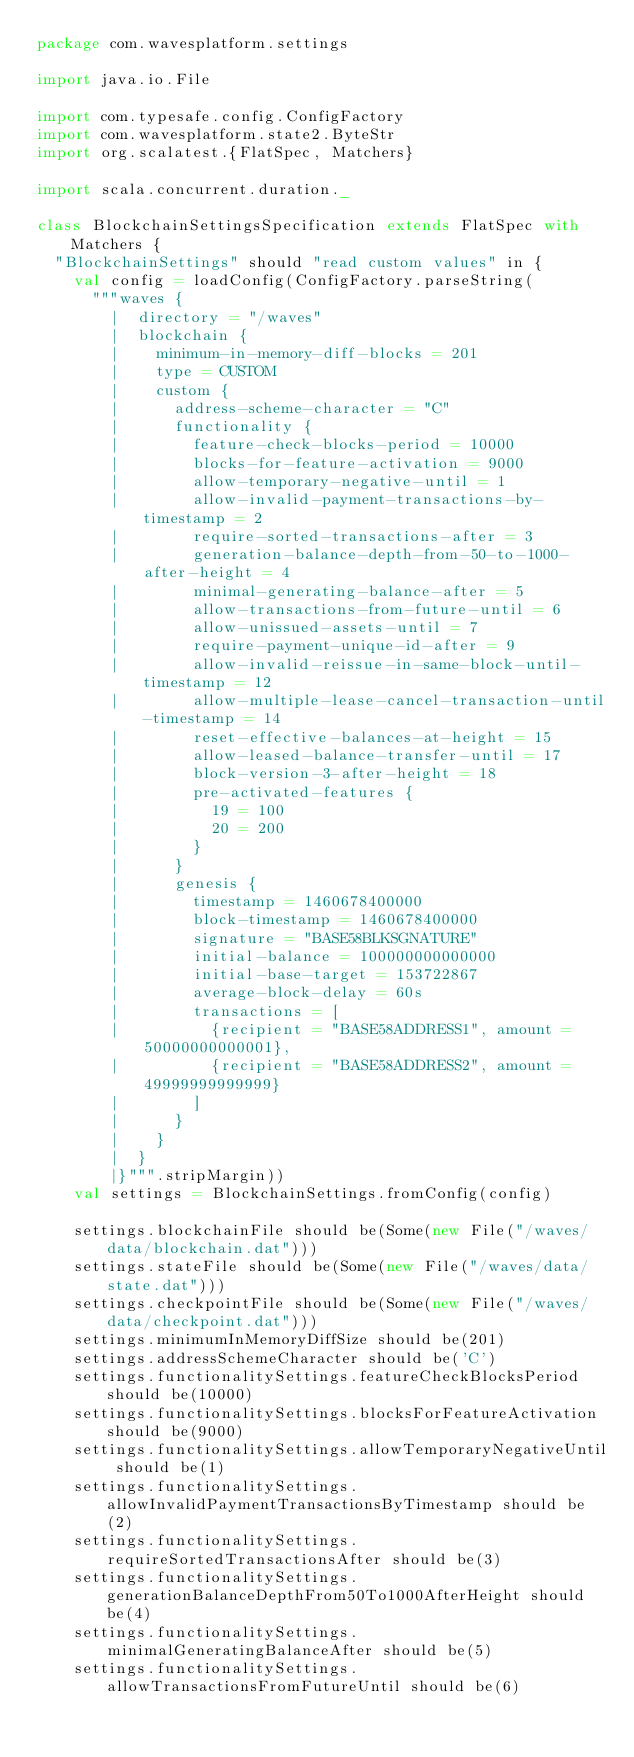<code> <loc_0><loc_0><loc_500><loc_500><_Scala_>package com.wavesplatform.settings

import java.io.File

import com.typesafe.config.ConfigFactory
import com.wavesplatform.state2.ByteStr
import org.scalatest.{FlatSpec, Matchers}

import scala.concurrent.duration._

class BlockchainSettingsSpecification extends FlatSpec with Matchers {
  "BlockchainSettings" should "read custom values" in {
    val config = loadConfig(ConfigFactory.parseString(
      """waves {
        |  directory = "/waves"
        |  blockchain {
        |    minimum-in-memory-diff-blocks = 201
        |    type = CUSTOM
        |    custom {
        |      address-scheme-character = "C"
        |      functionality {
        |        feature-check-blocks-period = 10000
        |        blocks-for-feature-activation = 9000
        |        allow-temporary-negative-until = 1
        |        allow-invalid-payment-transactions-by-timestamp = 2
        |        require-sorted-transactions-after = 3
        |        generation-balance-depth-from-50-to-1000-after-height = 4
        |        minimal-generating-balance-after = 5
        |        allow-transactions-from-future-until = 6
        |        allow-unissued-assets-until = 7
        |        require-payment-unique-id-after = 9
        |        allow-invalid-reissue-in-same-block-until-timestamp = 12
        |        allow-multiple-lease-cancel-transaction-until-timestamp = 14
        |        reset-effective-balances-at-height = 15
        |        allow-leased-balance-transfer-until = 17
        |        block-version-3-after-height = 18
        |        pre-activated-features {
        |          19 = 100
        |          20 = 200
        |        }
        |      }
        |      genesis {
        |        timestamp = 1460678400000
        |        block-timestamp = 1460678400000
        |        signature = "BASE58BLKSGNATURE"
        |        initial-balance = 100000000000000
        |        initial-base-target = 153722867
        |        average-block-delay = 60s
        |        transactions = [
        |          {recipient = "BASE58ADDRESS1", amount = 50000000000001},
        |          {recipient = "BASE58ADDRESS2", amount = 49999999999999}
        |        ]
        |      }
        |    }
        |  }
        |}""".stripMargin))
    val settings = BlockchainSettings.fromConfig(config)

    settings.blockchainFile should be(Some(new File("/waves/data/blockchain.dat")))
    settings.stateFile should be(Some(new File("/waves/data/state.dat")))
    settings.checkpointFile should be(Some(new File("/waves/data/checkpoint.dat")))
    settings.minimumInMemoryDiffSize should be(201)
    settings.addressSchemeCharacter should be('C')
    settings.functionalitySettings.featureCheckBlocksPeriod should be(10000)
    settings.functionalitySettings.blocksForFeatureActivation should be(9000)
    settings.functionalitySettings.allowTemporaryNegativeUntil should be(1)
    settings.functionalitySettings.allowInvalidPaymentTransactionsByTimestamp should be(2)
    settings.functionalitySettings.requireSortedTransactionsAfter should be(3)
    settings.functionalitySettings.generationBalanceDepthFrom50To1000AfterHeight should be(4)
    settings.functionalitySettings.minimalGeneratingBalanceAfter should be(5)
    settings.functionalitySettings.allowTransactionsFromFutureUntil should be(6)</code> 